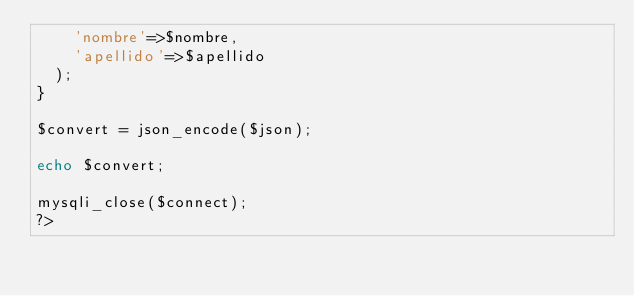<code> <loc_0><loc_0><loc_500><loc_500><_PHP_>    'nombre'=>$nombre,
    'apellido'=>$apellido 
  );
}

$convert = json_encode($json);

echo $convert;

mysqli_close($connect);
?></code> 